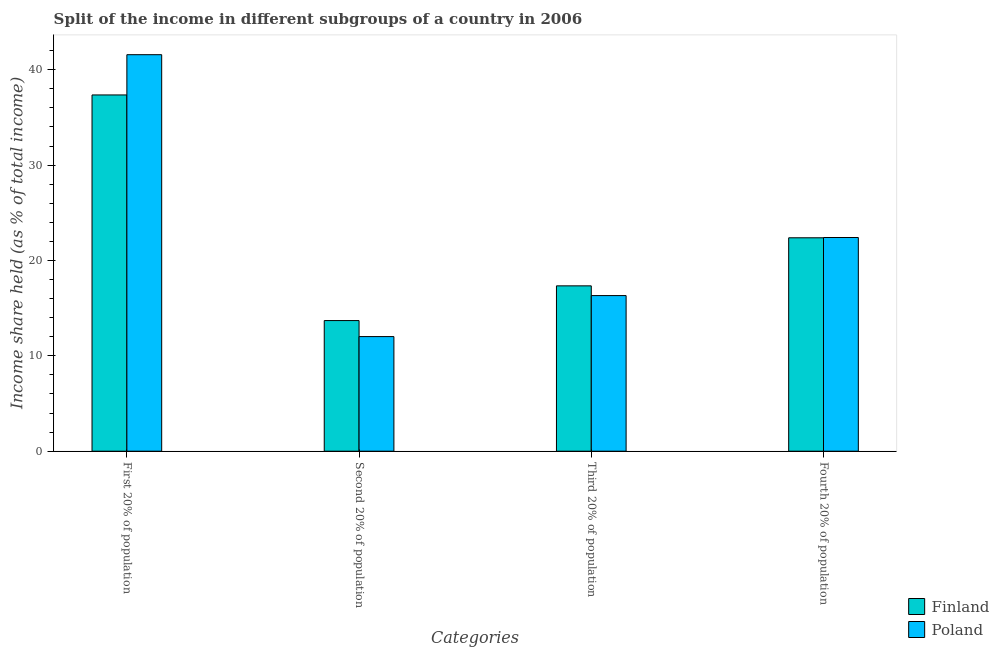Are the number of bars per tick equal to the number of legend labels?
Your answer should be compact. Yes. What is the label of the 4th group of bars from the left?
Your response must be concise. Fourth 20% of population. Across all countries, what is the maximum share of the income held by fourth 20% of the population?
Ensure brevity in your answer.  22.41. Across all countries, what is the minimum share of the income held by third 20% of the population?
Keep it short and to the point. 16.32. In which country was the share of the income held by third 20% of the population maximum?
Give a very brief answer. Finland. What is the total share of the income held by fourth 20% of the population in the graph?
Provide a short and direct response. 44.79. What is the difference between the share of the income held by fourth 20% of the population in Poland and that in Finland?
Make the answer very short. 0.03. What is the difference between the share of the income held by second 20% of the population in Finland and the share of the income held by first 20% of the population in Poland?
Offer a terse response. -27.88. What is the average share of the income held by fourth 20% of the population per country?
Keep it short and to the point. 22.39. What is the difference between the share of the income held by third 20% of the population and share of the income held by fourth 20% of the population in Finland?
Keep it short and to the point. -5.04. What is the ratio of the share of the income held by first 20% of the population in Finland to that in Poland?
Give a very brief answer. 0.9. What is the difference between the highest and the second highest share of the income held by first 20% of the population?
Offer a very short reply. 4.22. What is the difference between the highest and the lowest share of the income held by third 20% of the population?
Ensure brevity in your answer.  1.02. Is the sum of the share of the income held by first 20% of the population in Poland and Finland greater than the maximum share of the income held by second 20% of the population across all countries?
Ensure brevity in your answer.  Yes. Is it the case that in every country, the sum of the share of the income held by fourth 20% of the population and share of the income held by second 20% of the population is greater than the sum of share of the income held by first 20% of the population and share of the income held by third 20% of the population?
Your response must be concise. Yes. What does the 2nd bar from the left in First 20% of population represents?
Give a very brief answer. Poland. How many bars are there?
Your answer should be compact. 8. Are all the bars in the graph horizontal?
Provide a short and direct response. No. How many countries are there in the graph?
Give a very brief answer. 2. What is the difference between two consecutive major ticks on the Y-axis?
Make the answer very short. 10. Where does the legend appear in the graph?
Offer a very short reply. Bottom right. How many legend labels are there?
Provide a short and direct response. 2. What is the title of the graph?
Keep it short and to the point. Split of the income in different subgroups of a country in 2006. What is the label or title of the X-axis?
Offer a terse response. Categories. What is the label or title of the Y-axis?
Provide a succinct answer. Income share held (as % of total income). What is the Income share held (as % of total income) of Finland in First 20% of population?
Provide a succinct answer. 37.36. What is the Income share held (as % of total income) of Poland in First 20% of population?
Offer a terse response. 41.58. What is the Income share held (as % of total income) of Poland in Second 20% of population?
Ensure brevity in your answer.  12.02. What is the Income share held (as % of total income) of Finland in Third 20% of population?
Keep it short and to the point. 17.34. What is the Income share held (as % of total income) in Poland in Third 20% of population?
Give a very brief answer. 16.32. What is the Income share held (as % of total income) in Finland in Fourth 20% of population?
Provide a short and direct response. 22.38. What is the Income share held (as % of total income) of Poland in Fourth 20% of population?
Offer a very short reply. 22.41. Across all Categories, what is the maximum Income share held (as % of total income) in Finland?
Keep it short and to the point. 37.36. Across all Categories, what is the maximum Income share held (as % of total income) of Poland?
Give a very brief answer. 41.58. Across all Categories, what is the minimum Income share held (as % of total income) of Poland?
Your answer should be compact. 12.02. What is the total Income share held (as % of total income) of Finland in the graph?
Offer a very short reply. 90.78. What is the total Income share held (as % of total income) in Poland in the graph?
Make the answer very short. 92.33. What is the difference between the Income share held (as % of total income) in Finland in First 20% of population and that in Second 20% of population?
Provide a succinct answer. 23.66. What is the difference between the Income share held (as % of total income) in Poland in First 20% of population and that in Second 20% of population?
Offer a very short reply. 29.56. What is the difference between the Income share held (as % of total income) of Finland in First 20% of population and that in Third 20% of population?
Your response must be concise. 20.02. What is the difference between the Income share held (as % of total income) in Poland in First 20% of population and that in Third 20% of population?
Ensure brevity in your answer.  25.26. What is the difference between the Income share held (as % of total income) of Finland in First 20% of population and that in Fourth 20% of population?
Your answer should be very brief. 14.98. What is the difference between the Income share held (as % of total income) of Poland in First 20% of population and that in Fourth 20% of population?
Your answer should be very brief. 19.17. What is the difference between the Income share held (as % of total income) of Finland in Second 20% of population and that in Third 20% of population?
Make the answer very short. -3.64. What is the difference between the Income share held (as % of total income) of Poland in Second 20% of population and that in Third 20% of population?
Keep it short and to the point. -4.3. What is the difference between the Income share held (as % of total income) in Finland in Second 20% of population and that in Fourth 20% of population?
Offer a very short reply. -8.68. What is the difference between the Income share held (as % of total income) of Poland in Second 20% of population and that in Fourth 20% of population?
Your answer should be compact. -10.39. What is the difference between the Income share held (as % of total income) of Finland in Third 20% of population and that in Fourth 20% of population?
Make the answer very short. -5.04. What is the difference between the Income share held (as % of total income) in Poland in Third 20% of population and that in Fourth 20% of population?
Your answer should be very brief. -6.09. What is the difference between the Income share held (as % of total income) in Finland in First 20% of population and the Income share held (as % of total income) in Poland in Second 20% of population?
Ensure brevity in your answer.  25.34. What is the difference between the Income share held (as % of total income) in Finland in First 20% of population and the Income share held (as % of total income) in Poland in Third 20% of population?
Keep it short and to the point. 21.04. What is the difference between the Income share held (as % of total income) of Finland in First 20% of population and the Income share held (as % of total income) of Poland in Fourth 20% of population?
Your response must be concise. 14.95. What is the difference between the Income share held (as % of total income) of Finland in Second 20% of population and the Income share held (as % of total income) of Poland in Third 20% of population?
Your response must be concise. -2.62. What is the difference between the Income share held (as % of total income) in Finland in Second 20% of population and the Income share held (as % of total income) in Poland in Fourth 20% of population?
Your answer should be very brief. -8.71. What is the difference between the Income share held (as % of total income) of Finland in Third 20% of population and the Income share held (as % of total income) of Poland in Fourth 20% of population?
Your answer should be compact. -5.07. What is the average Income share held (as % of total income) of Finland per Categories?
Keep it short and to the point. 22.7. What is the average Income share held (as % of total income) of Poland per Categories?
Keep it short and to the point. 23.08. What is the difference between the Income share held (as % of total income) of Finland and Income share held (as % of total income) of Poland in First 20% of population?
Offer a very short reply. -4.22. What is the difference between the Income share held (as % of total income) in Finland and Income share held (as % of total income) in Poland in Second 20% of population?
Ensure brevity in your answer.  1.68. What is the difference between the Income share held (as % of total income) in Finland and Income share held (as % of total income) in Poland in Fourth 20% of population?
Keep it short and to the point. -0.03. What is the ratio of the Income share held (as % of total income) in Finland in First 20% of population to that in Second 20% of population?
Ensure brevity in your answer.  2.73. What is the ratio of the Income share held (as % of total income) in Poland in First 20% of population to that in Second 20% of population?
Make the answer very short. 3.46. What is the ratio of the Income share held (as % of total income) of Finland in First 20% of population to that in Third 20% of population?
Provide a succinct answer. 2.15. What is the ratio of the Income share held (as % of total income) in Poland in First 20% of population to that in Third 20% of population?
Provide a succinct answer. 2.55. What is the ratio of the Income share held (as % of total income) of Finland in First 20% of population to that in Fourth 20% of population?
Give a very brief answer. 1.67. What is the ratio of the Income share held (as % of total income) in Poland in First 20% of population to that in Fourth 20% of population?
Give a very brief answer. 1.86. What is the ratio of the Income share held (as % of total income) of Finland in Second 20% of population to that in Third 20% of population?
Your response must be concise. 0.79. What is the ratio of the Income share held (as % of total income) of Poland in Second 20% of population to that in Third 20% of population?
Your answer should be compact. 0.74. What is the ratio of the Income share held (as % of total income) in Finland in Second 20% of population to that in Fourth 20% of population?
Offer a terse response. 0.61. What is the ratio of the Income share held (as % of total income) in Poland in Second 20% of population to that in Fourth 20% of population?
Your answer should be very brief. 0.54. What is the ratio of the Income share held (as % of total income) of Finland in Third 20% of population to that in Fourth 20% of population?
Keep it short and to the point. 0.77. What is the ratio of the Income share held (as % of total income) in Poland in Third 20% of population to that in Fourth 20% of population?
Your answer should be compact. 0.73. What is the difference between the highest and the second highest Income share held (as % of total income) of Finland?
Ensure brevity in your answer.  14.98. What is the difference between the highest and the second highest Income share held (as % of total income) of Poland?
Give a very brief answer. 19.17. What is the difference between the highest and the lowest Income share held (as % of total income) of Finland?
Your answer should be very brief. 23.66. What is the difference between the highest and the lowest Income share held (as % of total income) in Poland?
Provide a short and direct response. 29.56. 